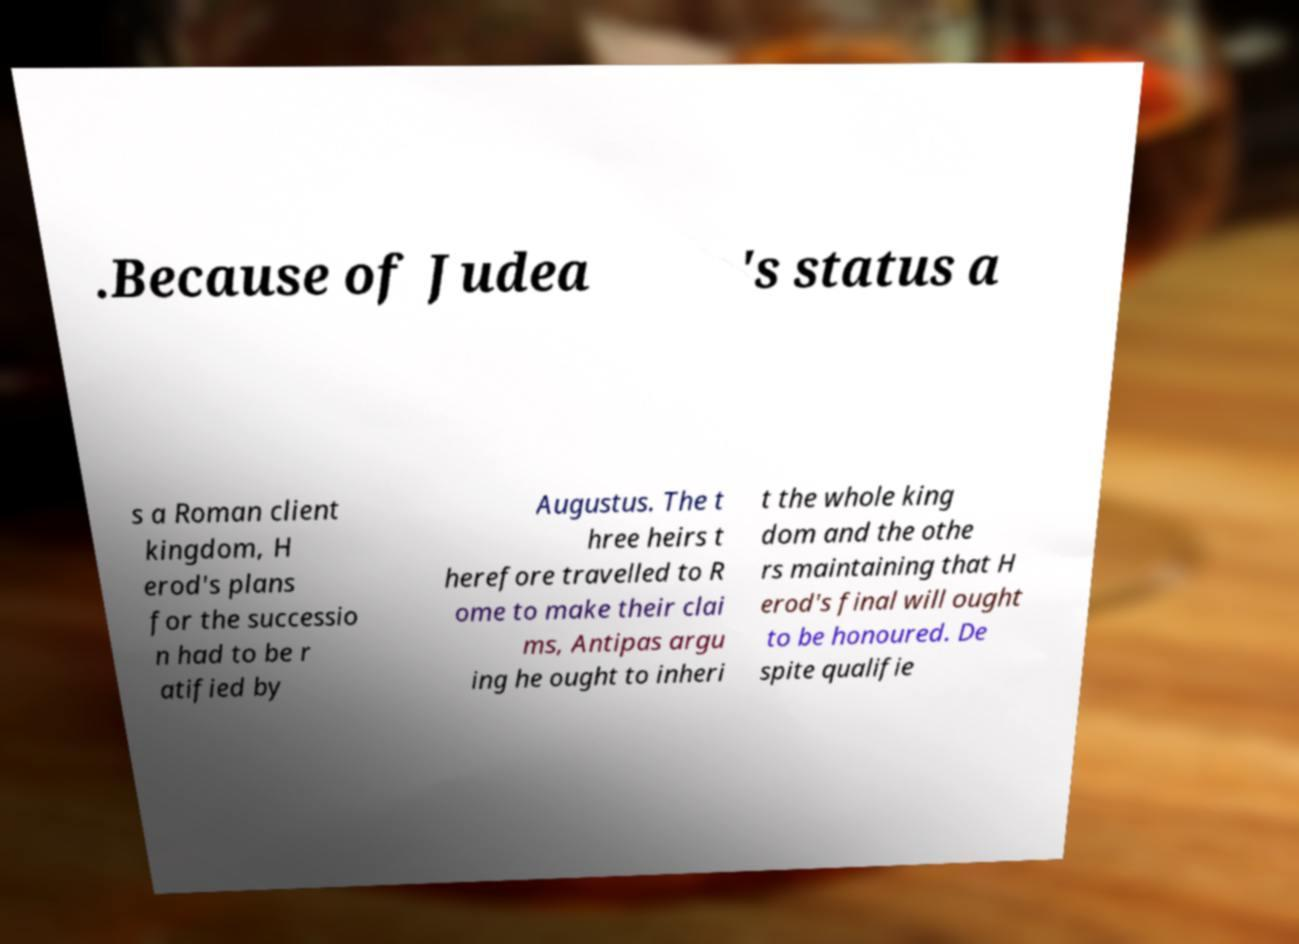Please read and relay the text visible in this image. What does it say? .Because of Judea 's status a s a Roman client kingdom, H erod's plans for the successio n had to be r atified by Augustus. The t hree heirs t herefore travelled to R ome to make their clai ms, Antipas argu ing he ought to inheri t the whole king dom and the othe rs maintaining that H erod's final will ought to be honoured. De spite qualifie 